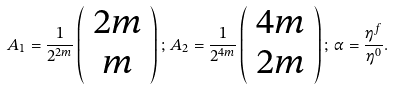Convert formula to latex. <formula><loc_0><loc_0><loc_500><loc_500>A _ { 1 } = \frac { 1 } { 2 ^ { 2 m } } \left ( \begin{array} { c } 2 m \\ m \end{array} \right ) ; \, A _ { 2 } = \frac { 1 } { 2 ^ { 4 m } } \left ( \begin{array} { c } 4 m \\ 2 m \end{array} \right ) ; \, \alpha = \frac { \eta ^ { f } } { \eta ^ { 0 } } .</formula> 